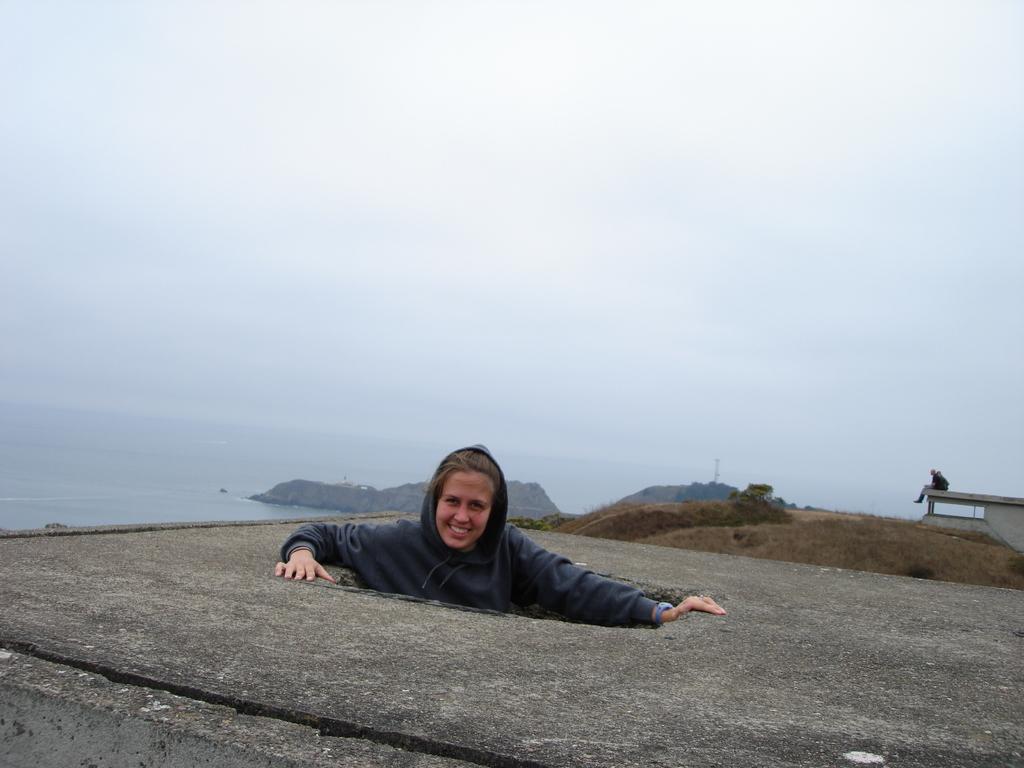Describe this image in one or two sentences. In this picture I can see a person wearing a hoodie. I can see a person sitting on the object on the right side. I can see water. I can see clouds in the sky. 